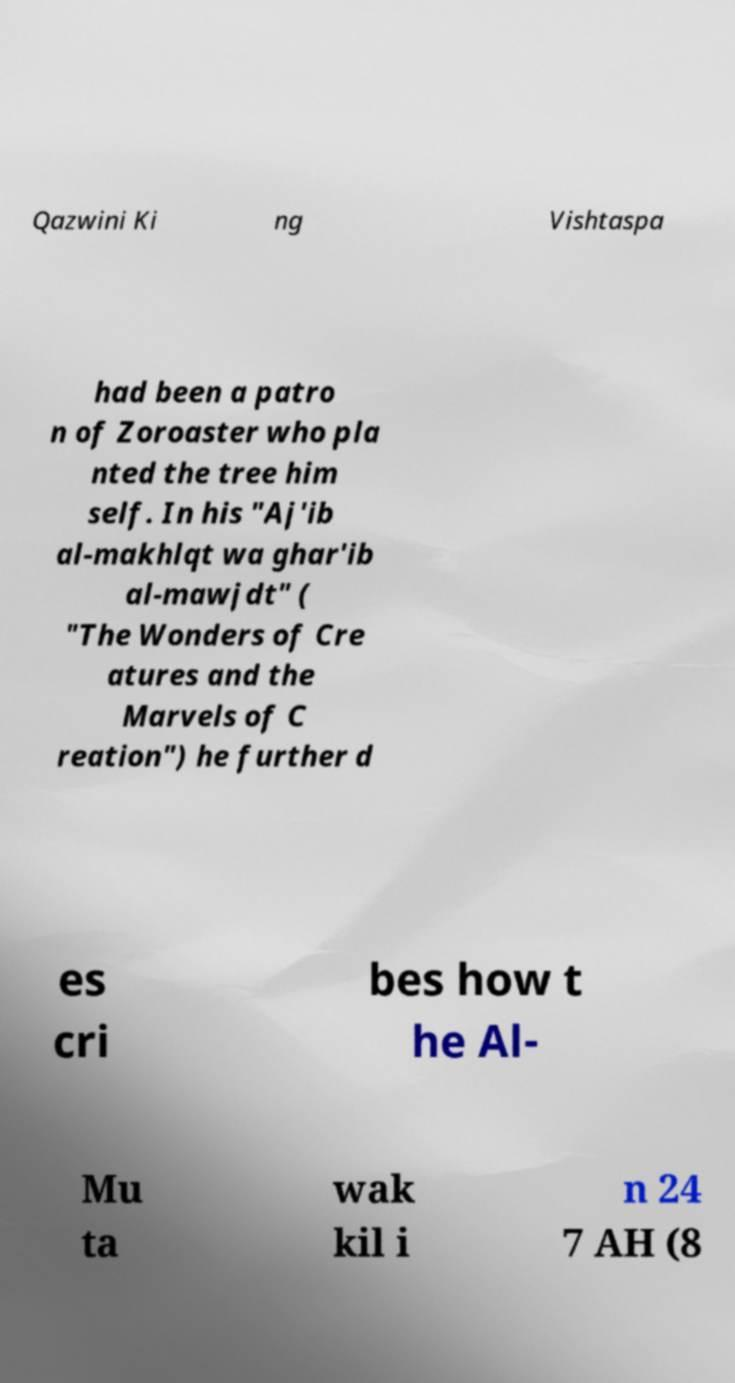What messages or text are displayed in this image? I need them in a readable, typed format. Qazwini Ki ng Vishtaspa had been a patro n of Zoroaster who pla nted the tree him self. In his "Aj'ib al-makhlqt wa ghar'ib al-mawjdt" ( "The Wonders of Cre atures and the Marvels of C reation") he further d es cri bes how t he Al- Mu ta wak kil i n 24 7 AH (8 